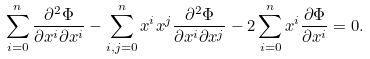<formula> <loc_0><loc_0><loc_500><loc_500>\sum _ { i = 0 } ^ { n } \frac { \partial ^ { 2 } \Phi } { \partial x ^ { i } \partial x ^ { i } } - \sum _ { i , j = 0 } ^ { n } x ^ { i } x ^ { j } \frac { \partial ^ { 2 } \Phi } { \partial x ^ { i } \partial x ^ { j } } - 2 \sum _ { i = 0 } ^ { n } x ^ { i } \frac { \partial \Phi } { \partial x ^ { i } } = 0 .</formula> 